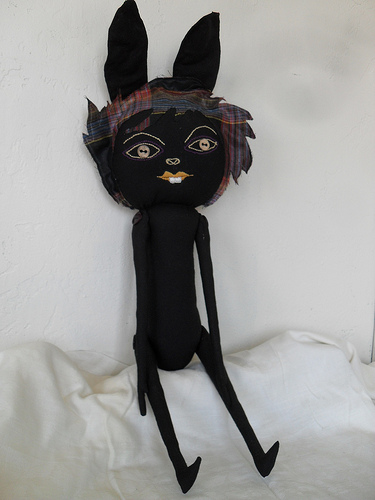<image>
Is the stuffed animal in the pillow? No. The stuffed animal is not contained within the pillow. These objects have a different spatial relationship. 